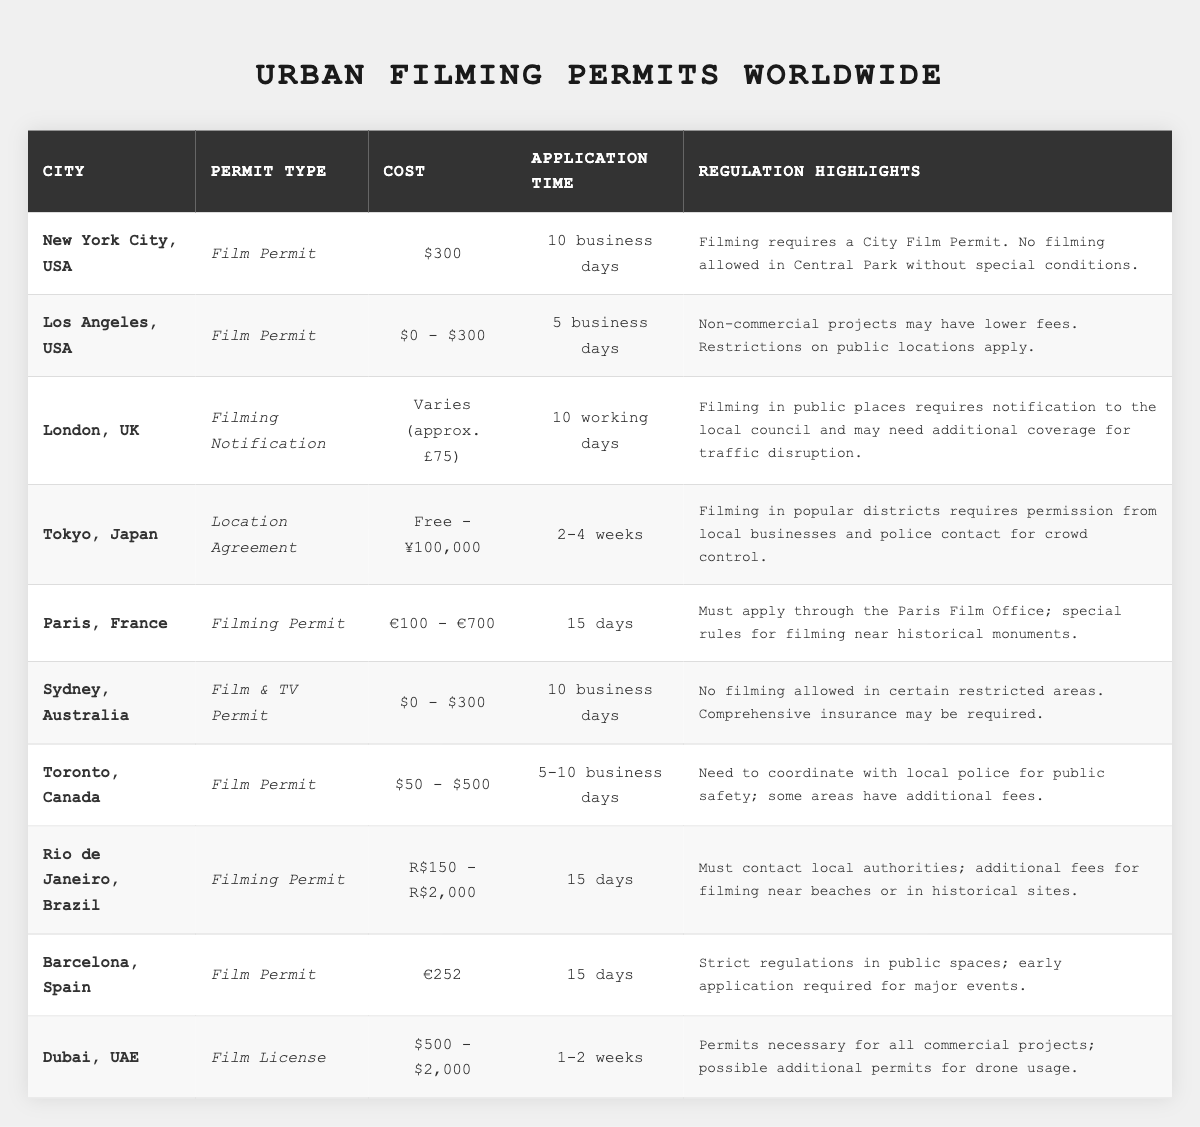What is the permit cost range for filming in Los Angeles? The table shows that the permit cost in Los Angeles ranges from $0 to $300.
Answer: $0 - $300 How many cities require an application time of 15 days or more? From the table, Paris, Rio de Janeiro, and Barcelona each require an application time of 15 days. Therefore, there are three cities with that requirement.
Answer: 3 Is filming allowed in Central Park without special conditions? According to the regulation highlights for New York City, filming is not allowed in Central Park without special conditions, making this statement false.
Answer: No Which city has the longest application time, and how long is it? The longest application time listed is for Tokyo, which ranges from 2 to 4 weeks, making it the longest application time among the cities in the table.
Answer: Tokyo, 2-4 weeks What is the average permit cost from the cities that have a specified range (not fixed cost)? The cities with specified ranges are Los Angeles ($0 - $300), Tokyo (Free - ¥100,000), Toronto ($50 - $500), Rio de Janeiro (R$150 - R$2,000), Dubai ($500 - $2,000). Summing the approximate midpoints gives $150 + ¥50,000 + $275 + R$1,075 + $1,250, which needs conversion for standardization, leading to an approximate average of $563.
Answer: ~$563 Which two cities have the same application time of 10 days? The cities with an application time of 10 days are New York City and London. This is retrieved by checking the application times in the table, both of which match 10 days.
Answer: New York City and London Is there any city that allows filming without any permit cost? Yes, the data shows that Tokyo might be free, indicating that at least one city allows filming without cost.
Answer: Yes What type of permit do most cities require for filming? Based on the table, the most common permit type is the "Film Permit," which is listed for New York City, Los Angeles, Toronto, Sydney, Rio de Janeiro, and Barcelona. This makes it the most frequent type.
Answer: Film Permit Which city requires the most complex regulations due to historical monuments? Paris has special rules for filming near historical monuments as highlighted in its regulation notes. Thus, it has the most complex regulations related to that context.
Answer: Paris What is the difference in application time between Tokyo and Barcelona? Tokyo has an application time of 2-4 weeks, while Barcelona has a fixed application time of 15 days. Converting weeks to days gives Tokyo a potential maximum of 28 days, resulting in a maximum difference of 13 days.
Answer: 13 days 